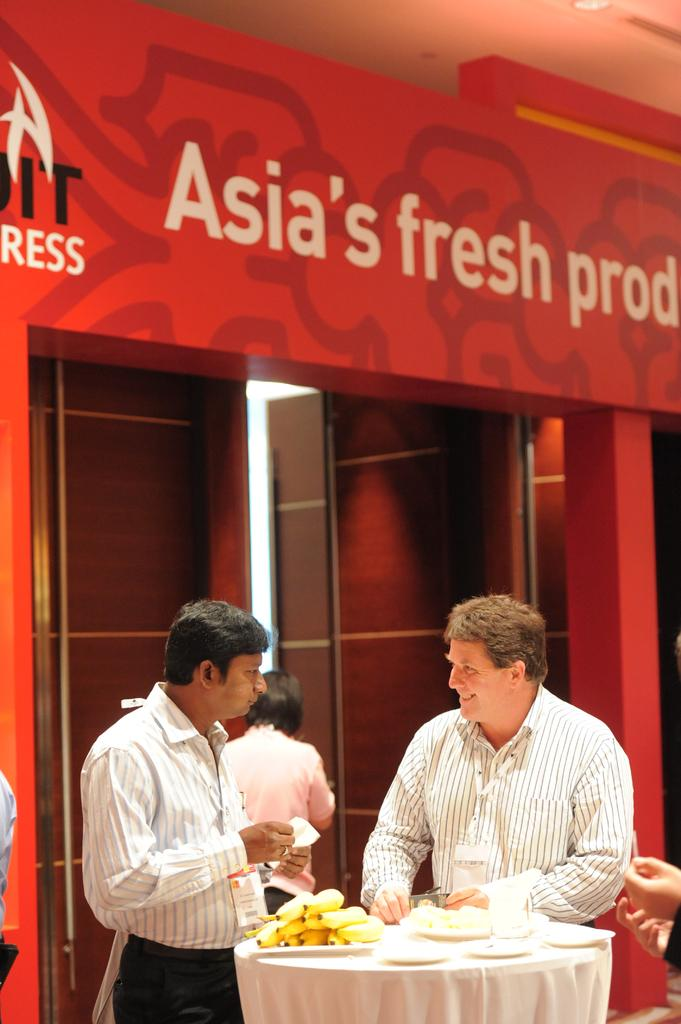How many people are in the image? There are people in the image, but the exact number cannot be determined from the provided facts. What is on the table in the image? There is a table in the image, and on it are bananas, plates, and a glass. What can be seen on the wall in the image? There is text on the wall in the image. What type of light is visible in the image? There is a light in the image, but the specific type cannot be determined from the provided facts. What is the purpose of the door in the image? The purpose of the door in the image cannot be determined from the provided facts. What type of hospital is depicted in the image? There is no mention of a hospital in the provided facts, so it cannot be determined if one is depicted in the image. 